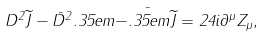<formula> <loc_0><loc_0><loc_500><loc_500>D ^ { 2 } \widetilde { J } - \bar { D } ^ { 2 } . 3 5 e m \bar { - . 3 5 e m \widetilde { J } } = 2 4 i \partial ^ { \mu } Z _ { \mu } ,</formula> 